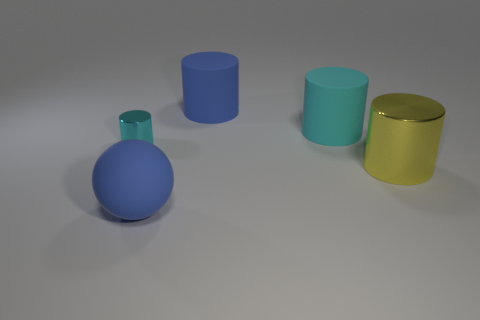Subtract all tiny cylinders. How many cylinders are left? 3 Add 4 tiny cylinders. How many tiny cylinders exist? 5 Add 1 big metal objects. How many objects exist? 6 Subtract all blue cylinders. How many cylinders are left? 3 Subtract 0 brown cubes. How many objects are left? 5 Subtract all cylinders. How many objects are left? 1 Subtract 3 cylinders. How many cylinders are left? 1 Subtract all green cylinders. Subtract all yellow blocks. How many cylinders are left? 4 Subtract all red balls. How many green cylinders are left? 0 Subtract all blue rubber objects. Subtract all yellow cylinders. How many objects are left? 2 